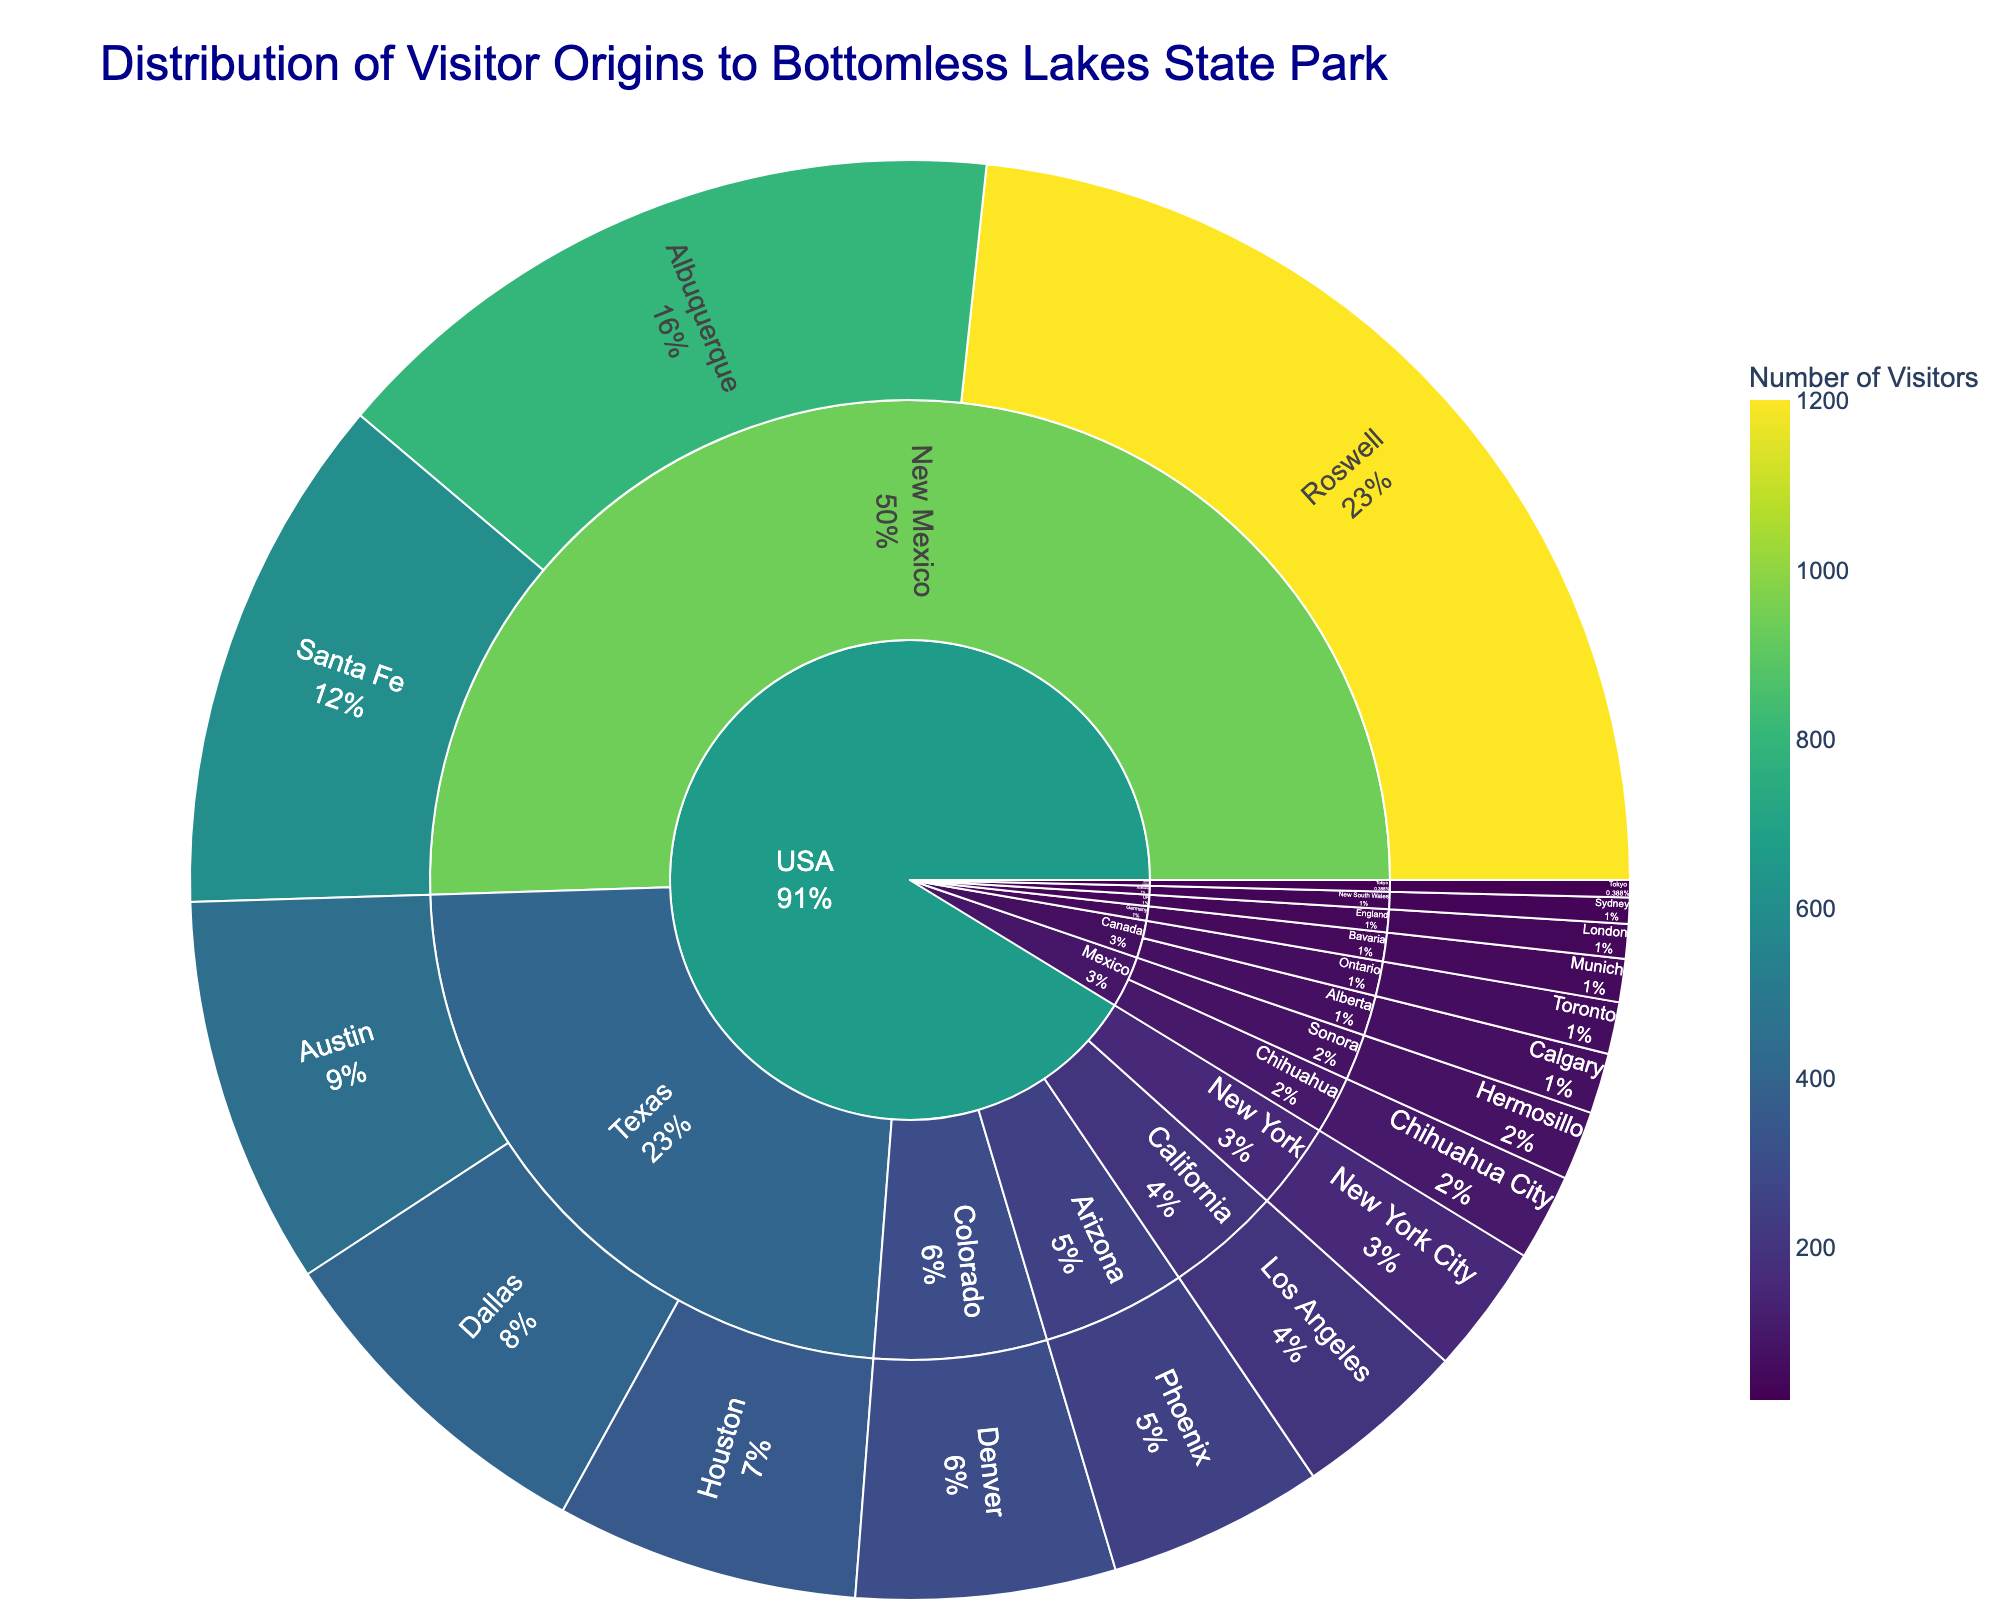What's the title of the plot? The title is displayed prominently at the top of the figure to provide context for the data shown.
Answer: Distribution of Visitor Origins to Bottomless Lakes State Park How many visitors came from Albuquerque, New Mexico? To find the number, you look at the portion of the sunburst plot for Albuquerque, New Mexico within the USA/New Mexico section. It has the count displayed as 800 visitors.
Answer: 800 Which city contributed the highest number of visitors? By observing the sizes of the sections within each state and country, the largest section corresponds to Roswell, New Mexico, with 1200 visitors.
Answer: Roswell What percentage of visitors are from Roswell, New Mexico? The percentage of visitors from Roswell, New Mexico is shown in the figure as part of the Roswell section. It displays both count and percentage.
Answer: The exact percentage displayed in the plot Which country has the smallest representation of visitors? The smallest sections on the outer ring of the sunburst plot indicate fewer visitors. Japan has the smallest section with only 20 visitors.
Answer: Japan What is the total number of visitors from Texas? Add the number of visitors from Austin (450), Dallas (400), and Houston (350): 450 + 400 + 350 = 1200.
Answer: 1200 How do the number of visitors from Houston, Texas compare to those from Denver, Colorado? Compare the size of the sections or the numbers provided for both cities. Houston has 350 visitors, whereas Denver has 300. Thus, Houston has more visitors.
Answer: Houston has more Which city in Mexico has more visitors, Chihuahua City or Hermosillo? Look at the sections corresponding to Chihuahua City and Hermosillo under Mexico. Chihuahua City has 100 visitors while Hermosillo has 80 visitors.
Answer: Chihuahua City What are the total visitors from the top three contributing cities in New Mexico? Sum the visitors from Roswell (1200), Albuquerque (800), and Santa Fe (600): 1200 + 800 + 600 = 2600.
Answer: 2600 What is the distribution of visitors from Germany and the UK combined? Germany (50 from Munich) and the UK (40 from London) total 50 + 40 = 90 visitors.
Answer: 90 